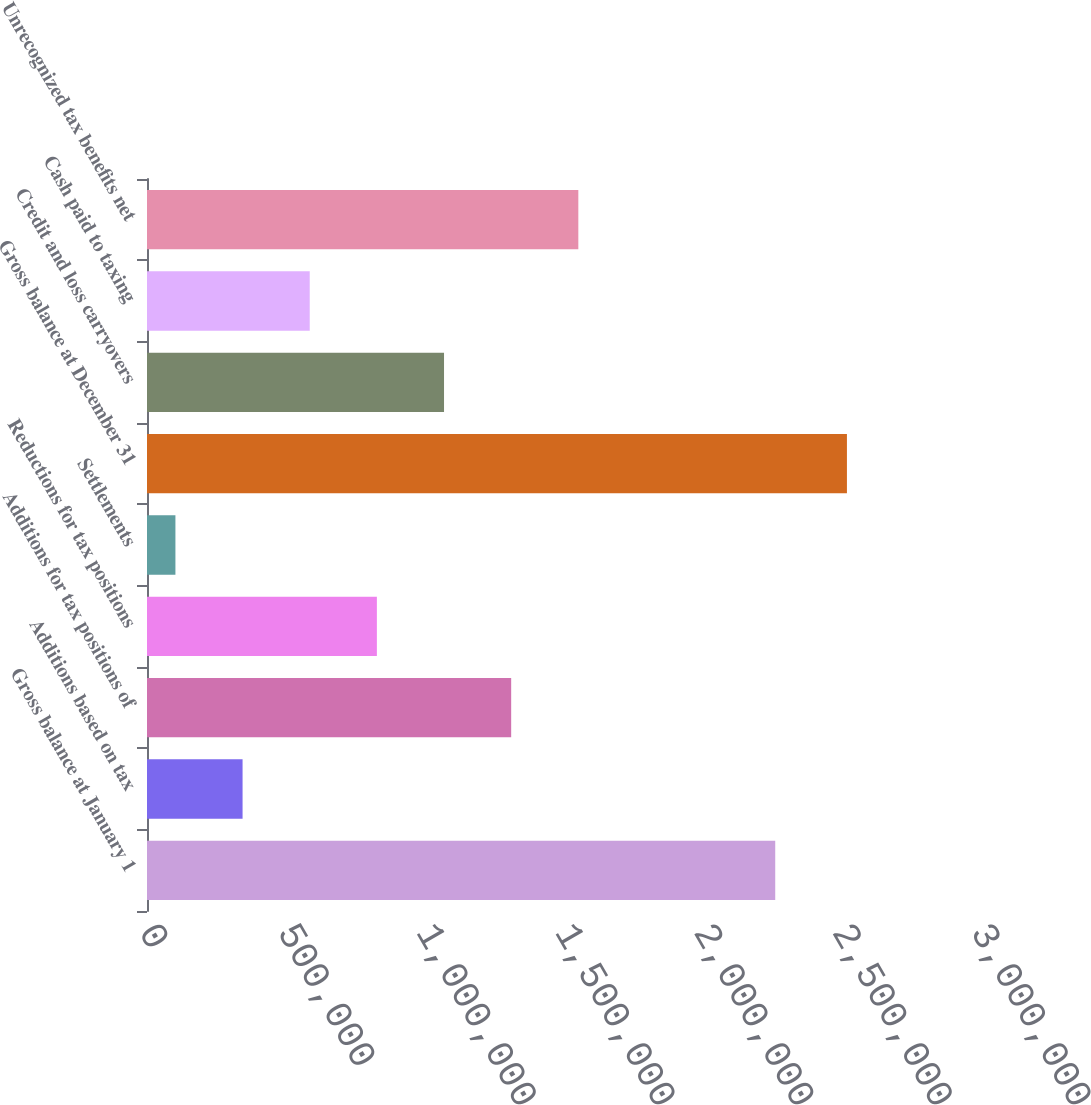Convert chart. <chart><loc_0><loc_0><loc_500><loc_500><bar_chart><fcel>Gross balance at January 1<fcel>Additions based on tax<fcel>Additions for tax positions of<fcel>Reductions for tax positions<fcel>Settlements<fcel>Gross balance at December 31<fcel>Credit and loss carryovers<fcel>Cash paid to taxing<fcel>Unrecognized tax benefits net<nl><fcel>2.26526e+06<fcel>344616<fcel>1.31314e+06<fcel>828878<fcel>102485<fcel>2.52379e+06<fcel>1.07101e+06<fcel>586747<fcel>1.55527e+06<nl></chart> 